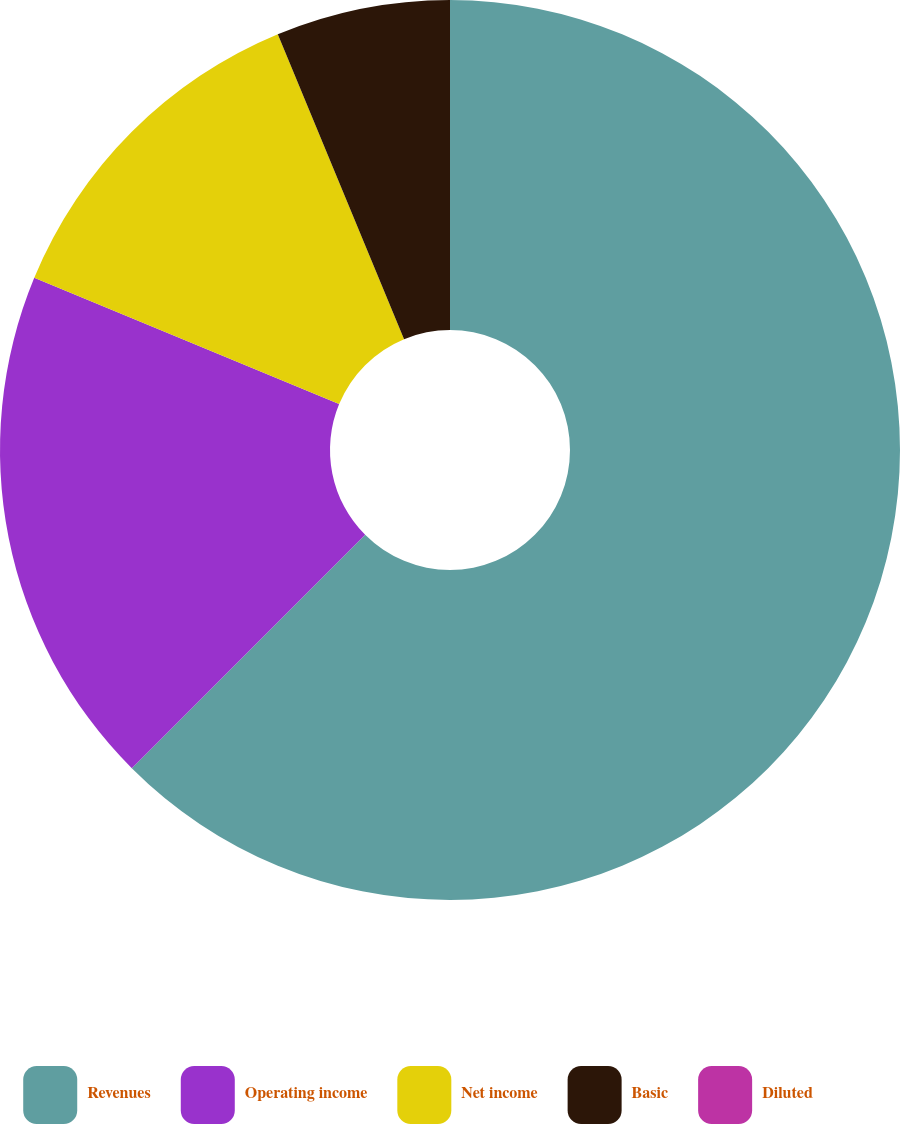Convert chart to OTSL. <chart><loc_0><loc_0><loc_500><loc_500><pie_chart><fcel>Revenues<fcel>Operating income<fcel>Net income<fcel>Basic<fcel>Diluted<nl><fcel>62.5%<fcel>18.75%<fcel>12.5%<fcel>6.25%<fcel>0.0%<nl></chart> 